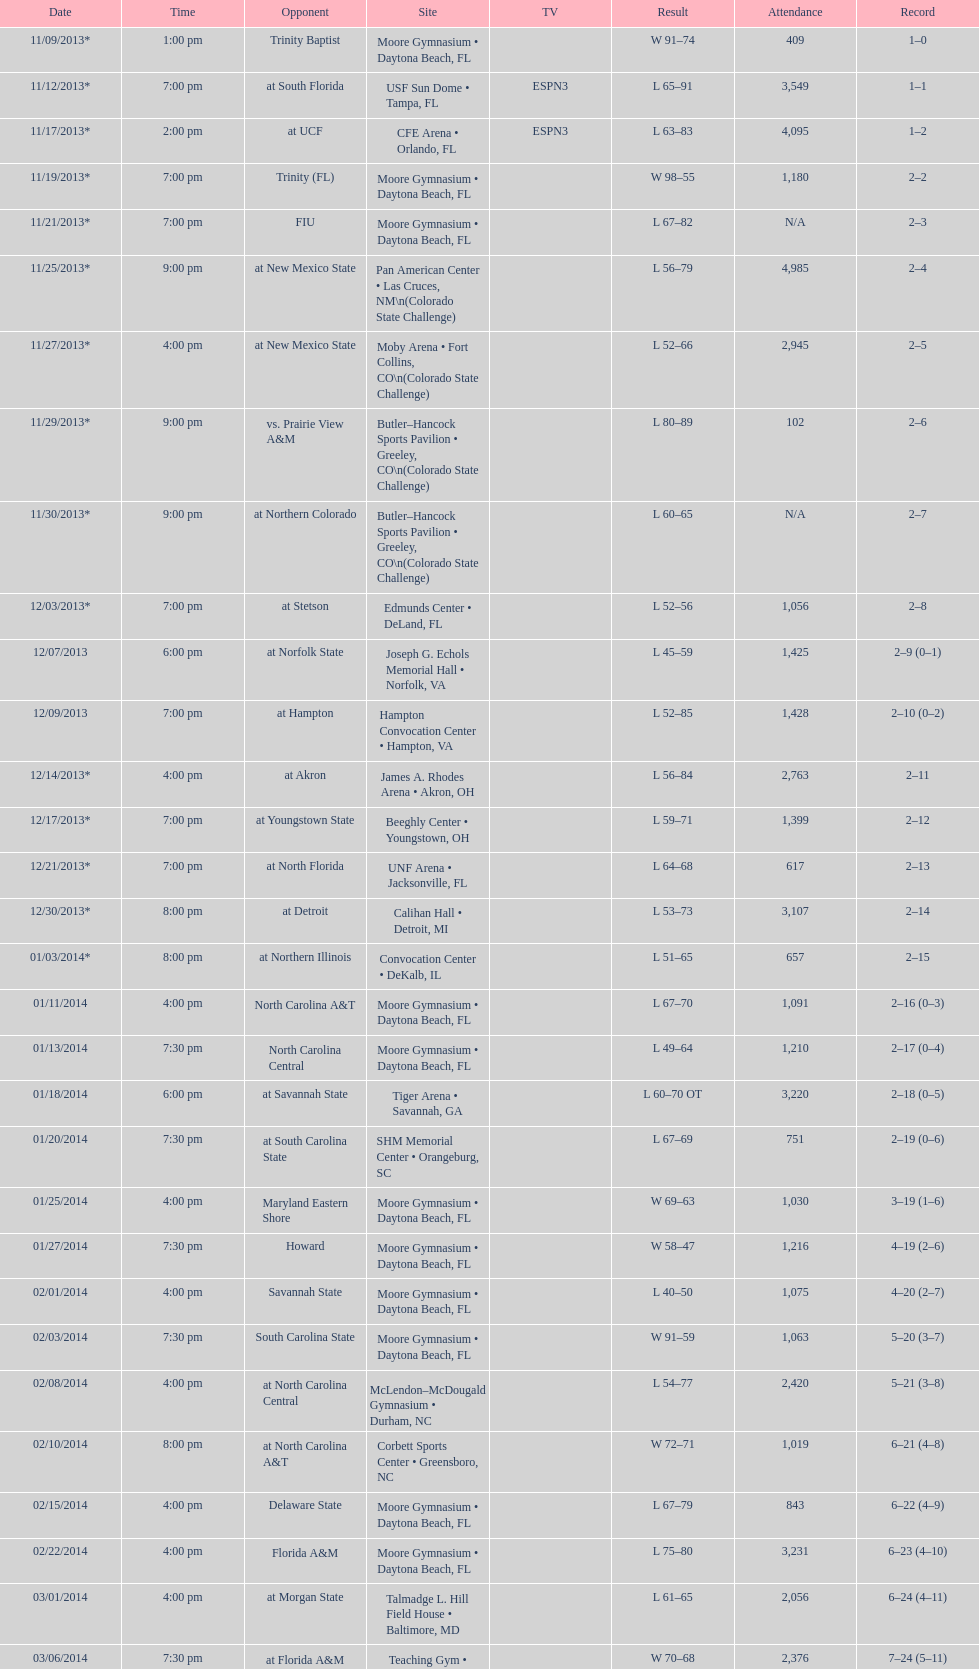Which game took place more into the night, fiu or northern colorado? Northern Colorado. 